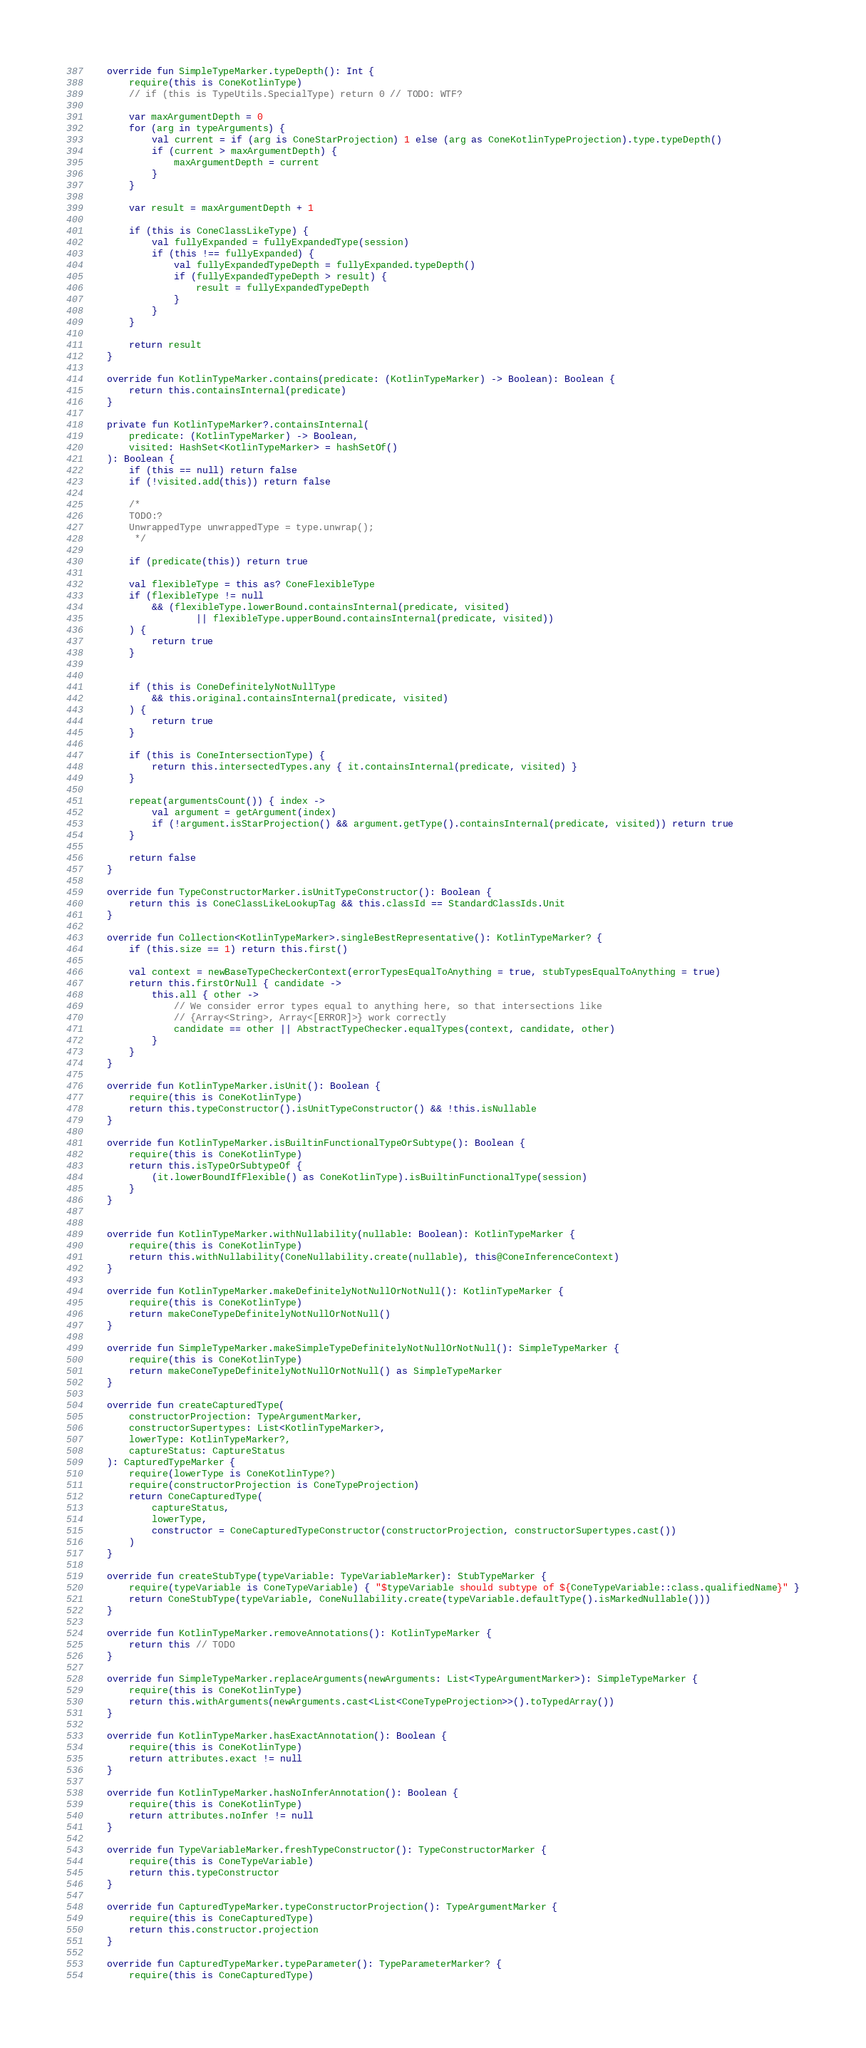<code> <loc_0><loc_0><loc_500><loc_500><_Kotlin_>
    override fun SimpleTypeMarker.typeDepth(): Int {
        require(this is ConeKotlinType)
        // if (this is TypeUtils.SpecialType) return 0 // TODO: WTF?

        var maxArgumentDepth = 0
        for (arg in typeArguments) {
            val current = if (arg is ConeStarProjection) 1 else (arg as ConeKotlinTypeProjection).type.typeDepth()
            if (current > maxArgumentDepth) {
                maxArgumentDepth = current
            }
        }

        var result = maxArgumentDepth + 1

        if (this is ConeClassLikeType) {
            val fullyExpanded = fullyExpandedType(session)
            if (this !== fullyExpanded) {
                val fullyExpandedTypeDepth = fullyExpanded.typeDepth()
                if (fullyExpandedTypeDepth > result) {
                    result = fullyExpandedTypeDepth
                }
            }
        }

        return result
    }

    override fun KotlinTypeMarker.contains(predicate: (KotlinTypeMarker) -> Boolean): Boolean {
        return this.containsInternal(predicate)
    }

    private fun KotlinTypeMarker?.containsInternal(
        predicate: (KotlinTypeMarker) -> Boolean,
        visited: HashSet<KotlinTypeMarker> = hashSetOf()
    ): Boolean {
        if (this == null) return false
        if (!visited.add(this)) return false

        /*
        TODO:?
        UnwrappedType unwrappedType = type.unwrap();
         */

        if (predicate(this)) return true

        val flexibleType = this as? ConeFlexibleType
        if (flexibleType != null
            && (flexibleType.lowerBound.containsInternal(predicate, visited)
                    || flexibleType.upperBound.containsInternal(predicate, visited))
        ) {
            return true
        }


        if (this is ConeDefinitelyNotNullType
            && this.original.containsInternal(predicate, visited)
        ) {
            return true
        }

        if (this is ConeIntersectionType) {
            return this.intersectedTypes.any { it.containsInternal(predicate, visited) }
        }

        repeat(argumentsCount()) { index ->
            val argument = getArgument(index)
            if (!argument.isStarProjection() && argument.getType().containsInternal(predicate, visited)) return true
        }

        return false
    }

    override fun TypeConstructorMarker.isUnitTypeConstructor(): Boolean {
        return this is ConeClassLikeLookupTag && this.classId == StandardClassIds.Unit
    }

    override fun Collection<KotlinTypeMarker>.singleBestRepresentative(): KotlinTypeMarker? {
        if (this.size == 1) return this.first()

        val context = newBaseTypeCheckerContext(errorTypesEqualToAnything = true, stubTypesEqualToAnything = true)
        return this.firstOrNull { candidate ->
            this.all { other ->
                // We consider error types equal to anything here, so that intersections like
                // {Array<String>, Array<[ERROR]>} work correctly
                candidate == other || AbstractTypeChecker.equalTypes(context, candidate, other)
            }
        }
    }

    override fun KotlinTypeMarker.isUnit(): Boolean {
        require(this is ConeKotlinType)
        return this.typeConstructor().isUnitTypeConstructor() && !this.isNullable
    }

    override fun KotlinTypeMarker.isBuiltinFunctionalTypeOrSubtype(): Boolean {
        require(this is ConeKotlinType)
        return this.isTypeOrSubtypeOf {
            (it.lowerBoundIfFlexible() as ConeKotlinType).isBuiltinFunctionalType(session)
        }
    }


    override fun KotlinTypeMarker.withNullability(nullable: Boolean): KotlinTypeMarker {
        require(this is ConeKotlinType)
        return this.withNullability(ConeNullability.create(nullable), this@ConeInferenceContext)
    }

    override fun KotlinTypeMarker.makeDefinitelyNotNullOrNotNull(): KotlinTypeMarker {
        require(this is ConeKotlinType)
        return makeConeTypeDefinitelyNotNullOrNotNull()
    }

    override fun SimpleTypeMarker.makeSimpleTypeDefinitelyNotNullOrNotNull(): SimpleTypeMarker {
        require(this is ConeKotlinType)
        return makeConeTypeDefinitelyNotNullOrNotNull() as SimpleTypeMarker
    }

    override fun createCapturedType(
        constructorProjection: TypeArgumentMarker,
        constructorSupertypes: List<KotlinTypeMarker>,
        lowerType: KotlinTypeMarker?,
        captureStatus: CaptureStatus
    ): CapturedTypeMarker {
        require(lowerType is ConeKotlinType?)
        require(constructorProjection is ConeTypeProjection)
        return ConeCapturedType(
            captureStatus,
            lowerType,
            constructor = ConeCapturedTypeConstructor(constructorProjection, constructorSupertypes.cast())
        )
    }

    override fun createStubType(typeVariable: TypeVariableMarker): StubTypeMarker {
        require(typeVariable is ConeTypeVariable) { "$typeVariable should subtype of ${ConeTypeVariable::class.qualifiedName}" }
        return ConeStubType(typeVariable, ConeNullability.create(typeVariable.defaultType().isMarkedNullable()))
    }

    override fun KotlinTypeMarker.removeAnnotations(): KotlinTypeMarker {
        return this // TODO
    }

    override fun SimpleTypeMarker.replaceArguments(newArguments: List<TypeArgumentMarker>): SimpleTypeMarker {
        require(this is ConeKotlinType)
        return this.withArguments(newArguments.cast<List<ConeTypeProjection>>().toTypedArray())
    }

    override fun KotlinTypeMarker.hasExactAnnotation(): Boolean {
        require(this is ConeKotlinType)
        return attributes.exact != null
    }

    override fun KotlinTypeMarker.hasNoInferAnnotation(): Boolean {
        require(this is ConeKotlinType)
        return attributes.noInfer != null
    }

    override fun TypeVariableMarker.freshTypeConstructor(): TypeConstructorMarker {
        require(this is ConeTypeVariable)
        return this.typeConstructor
    }

    override fun CapturedTypeMarker.typeConstructorProjection(): TypeArgumentMarker {
        require(this is ConeCapturedType)
        return this.constructor.projection
    }

    override fun CapturedTypeMarker.typeParameter(): TypeParameterMarker? {
        require(this is ConeCapturedType)</code> 